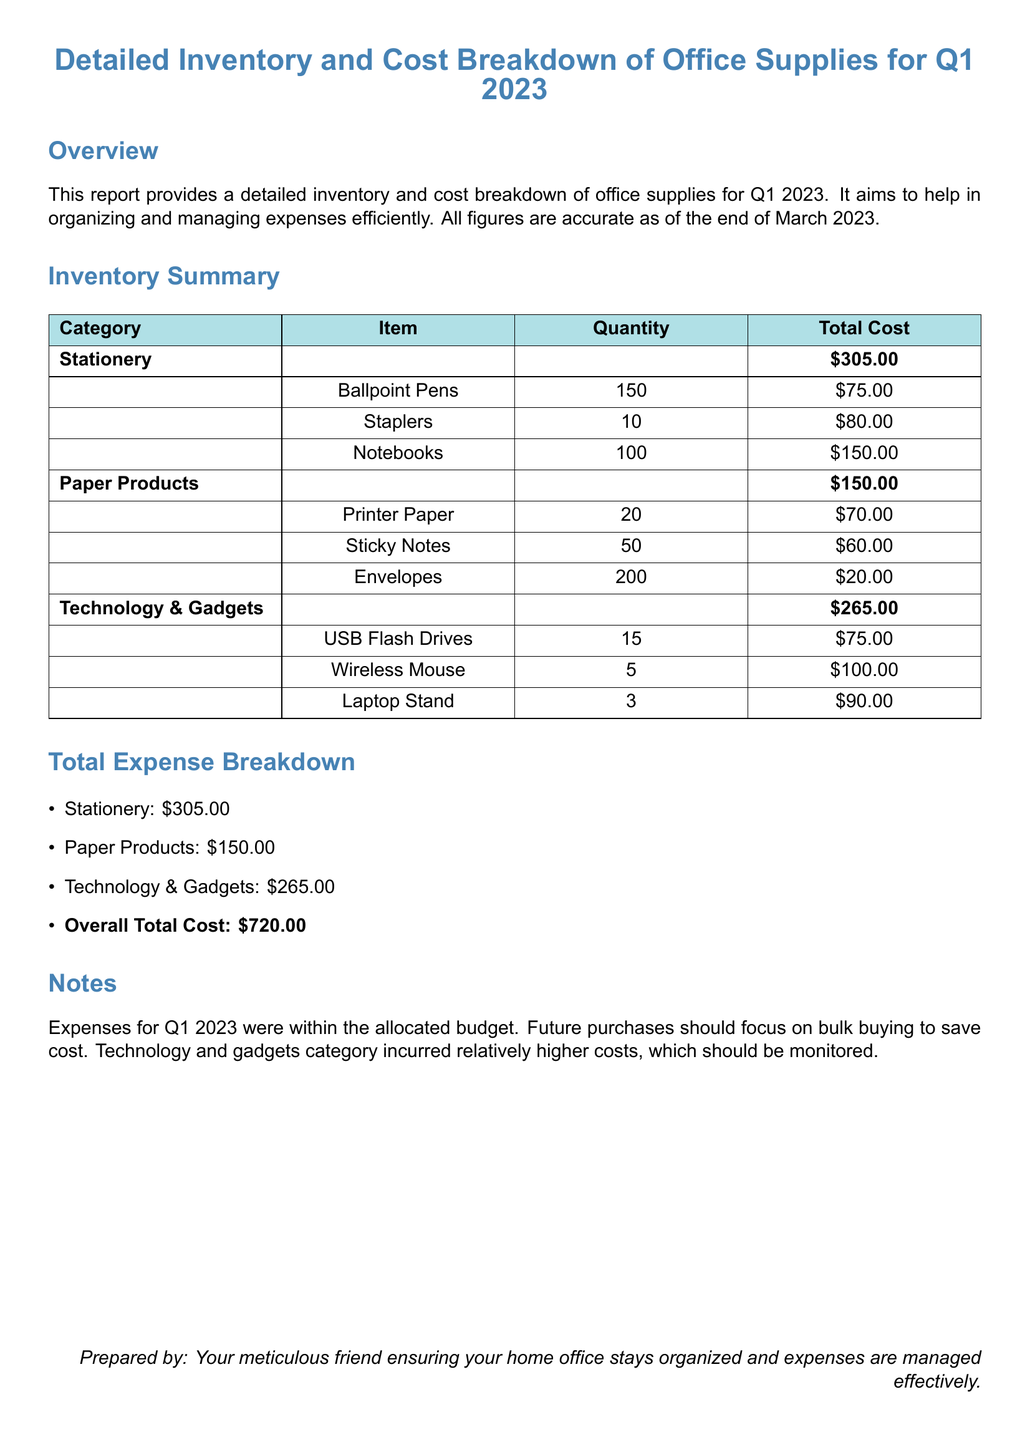what is the total cost of stationery? The total cost of stationery is specifically listed in the inventory summary section as $305.00.
Answer: $305.00 how many notebooks were purchased? The quantity of notebooks is provided under the stationery category, which states 100 notebooks were purchased.
Answer: 100 which category had the highest total cost? The highest total cost is determined by comparing the total costs listed for each category, which is technology and gadgets at $265.00.
Answer: Technology & Gadgets what is the overall total cost for Q1 2023? The overall total cost is provided in the total expense breakdown section, totaling $720.00.
Answer: $720.00 how many staplers were included in the inventory? The inventory summary lists 10 staplers under the stationery category.
Answer: 10 what was the total cost of paper products? The total cost of paper products is stated in the expense breakdown section as $150.00.
Answer: $150.00 how many USB flash drives were purchased? The inventory summary indicates that 15 USB flash drives were purchased.
Answer: 15 what is the purpose of this report? The report's purpose is stated in the overview section as organizing and managing expenses efficiently.
Answer: Organizing and managing expenses efficiently how should future purchases be oriented according to the report? The report suggests future purchases should focus on bulk buying to save cost as mentioned in the notes section.
Answer: Bulk buying to save cost 